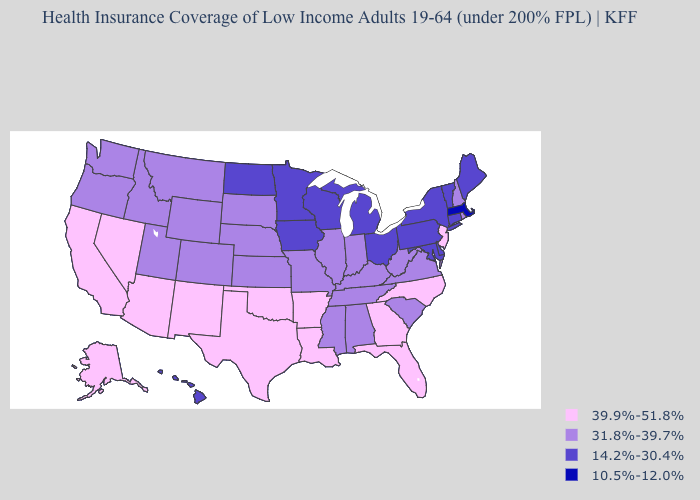Name the states that have a value in the range 39.9%-51.8%?
Keep it brief. Alaska, Arizona, Arkansas, California, Florida, Georgia, Louisiana, Nevada, New Jersey, New Mexico, North Carolina, Oklahoma, Texas. Does Hawaii have the highest value in the West?
Keep it brief. No. What is the lowest value in the Northeast?
Concise answer only. 10.5%-12.0%. Name the states that have a value in the range 10.5%-12.0%?
Write a very short answer. Massachusetts. What is the value of Minnesota?
Quick response, please. 14.2%-30.4%. Name the states that have a value in the range 14.2%-30.4%?
Write a very short answer. Connecticut, Delaware, Hawaii, Iowa, Maine, Maryland, Michigan, Minnesota, New York, North Dakota, Ohio, Pennsylvania, Vermont, Wisconsin. What is the value of Kentucky?
Answer briefly. 31.8%-39.7%. Does North Dakota have the highest value in the MidWest?
Concise answer only. No. What is the value of North Carolina?
Write a very short answer. 39.9%-51.8%. What is the value of Wyoming?
Write a very short answer. 31.8%-39.7%. What is the value of North Dakota?
Give a very brief answer. 14.2%-30.4%. Does Washington have the same value as Arizona?
Write a very short answer. No. What is the value of Utah?
Write a very short answer. 31.8%-39.7%. Which states have the lowest value in the West?
Answer briefly. Hawaii. How many symbols are there in the legend?
Short answer required. 4. 